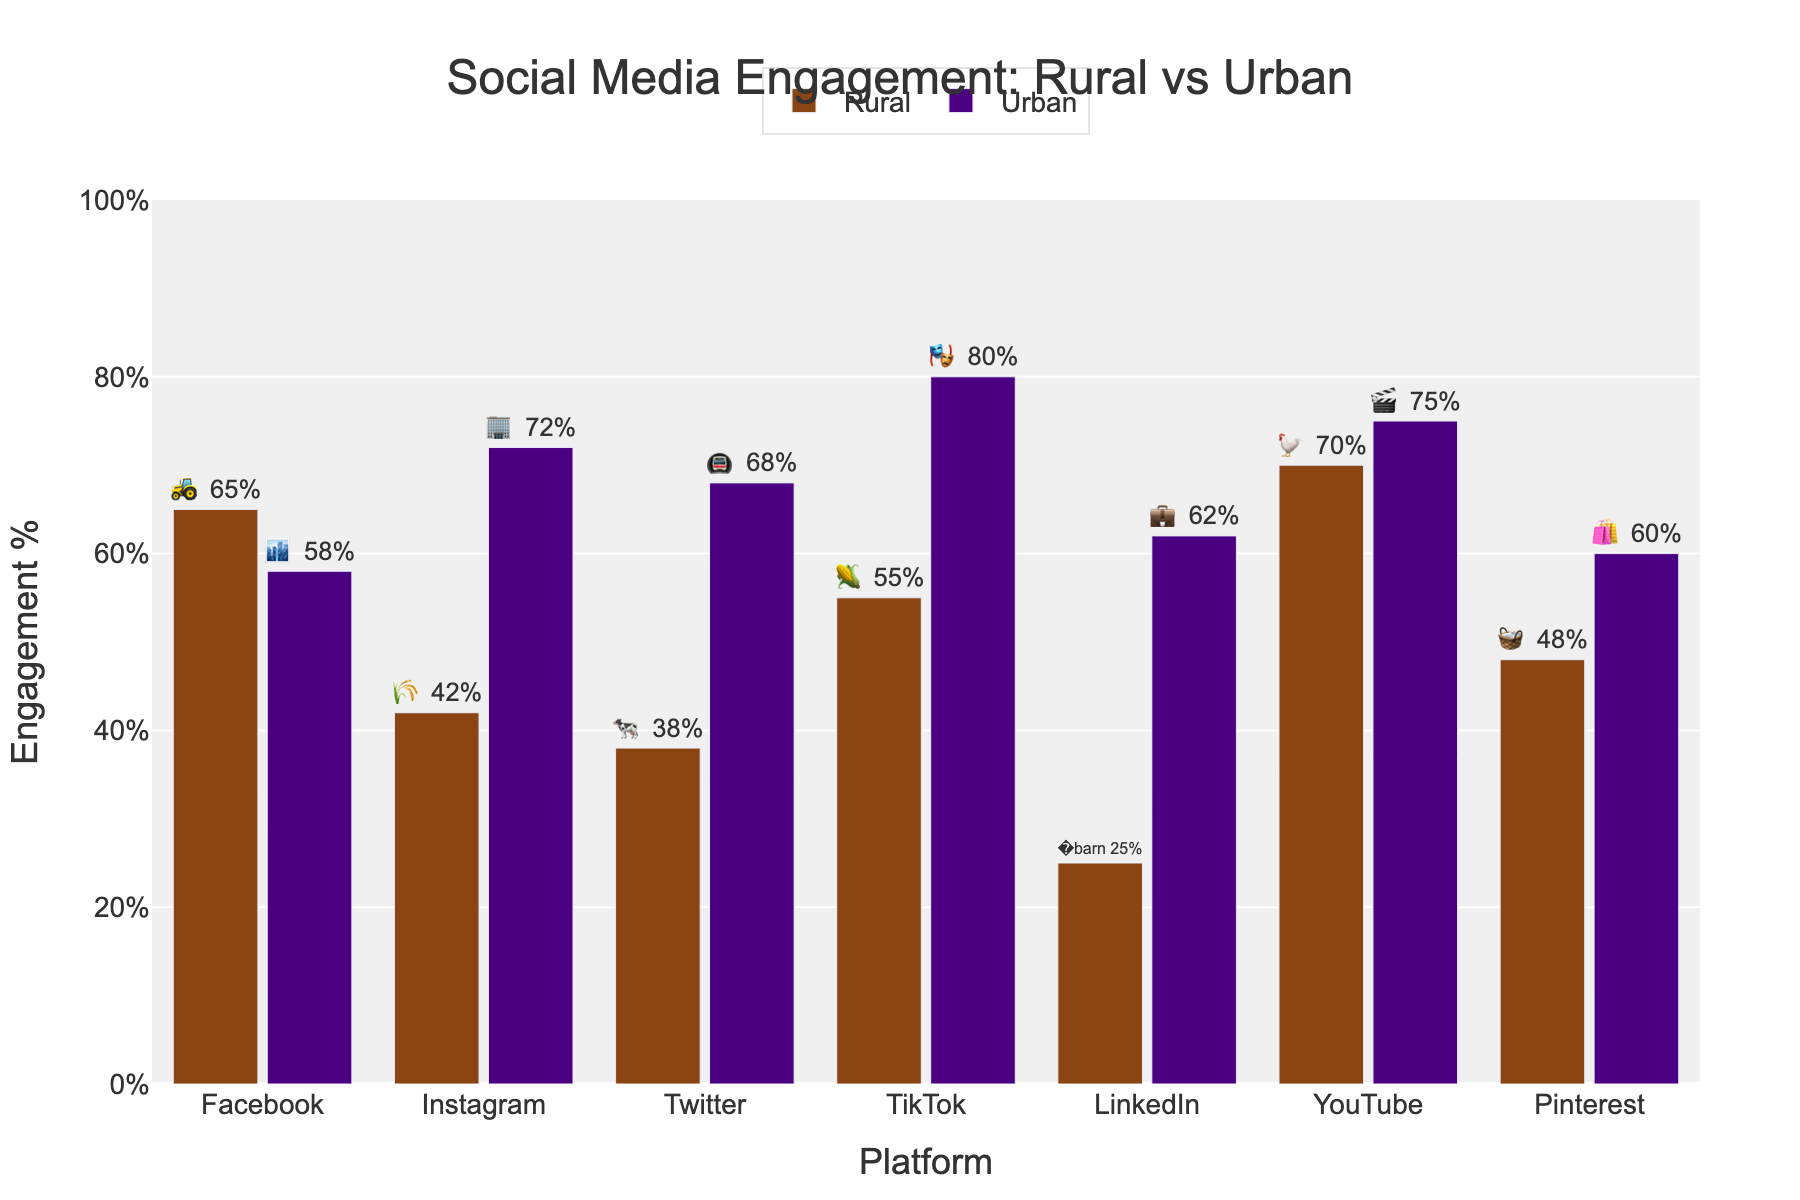What's the highest engagement percentage for the rural population? The highest engagement percentage for the rural population can be found by looking at the tallest bar labeled with a rural emoji in the figure. This bar is for YouTube, with a percentage of 70%.
Answer: 70% Which platform shows the largest difference in engagement between rural and urban populations? To find the platform with the largest difference, we subtract the rural engagement percentage from the urban engagement percentage for each platform, then identify the platform with the largest absolute difference. For TikTok, the difference is 80% - 55% = 25%.
Answer: TikTok On which platform is the rural engagement higher than urban engagement? By comparing each platform, we identify the bar with the rural emoji that is taller than its corresponding urban bar. For Facebook, the rural engagement is 65%, higher than the urban engagement of 58%.
Answer: Facebook What is the average engagement percentage for urban populations across all platforms? Add up the urban engagement percentages for all platforms and divide by the number of platforms. This is (58 + 72 + 68 + 80 + 62 + 75 + 60)/7. Thus, the sum is 475, and the average is 475/7 ≈ 67.86%.
Answer: 67.86% Which platform has the smallest engagement percentage for rural populations? Identify the shortest bar labeled with a rural emoji in the figure. This bar is for LinkedIn, with a percentage of 25%.
Answer: LinkedIn How much higher is Instagram engagement in urban areas compared to rural areas? Look at the engagement percentages for Instagram: Rural engagement is 42%, and urban engagement is 72%. Subtract rural from urban: 72% - 42% = 30%.
Answer: 30% Is there any platform where rural engagement is equal to or higher than 70%? Check each rural bar for the engagement percentages. YouTube has a rural engagement of 70%, which meets the criteria.
Answer: Yes, YouTube What are the engagement percentages for Facebook for both rural and urban populations? Refer to the bars labeled with the Facebook icon. The rural engagement percentage is 65%, while the urban engagement percentage is 58%.
Answer: 65% (Rural), 58% (Urban) Which platform shows the smallest difference in engagement percentages between rural and urban populations? Calculate the absolute difference for each platform. For Pinterest, the difference is 60% - 48% = 12%. This is the smallest difference when compared to the other platforms.
Answer: Pinterest 